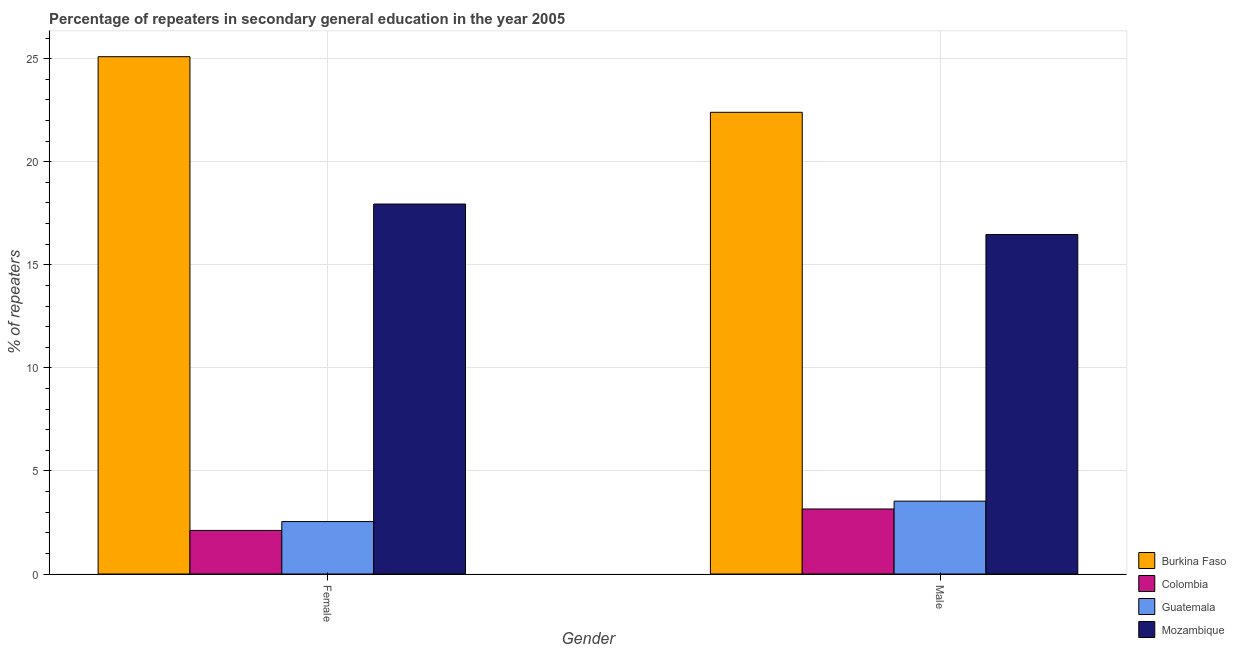How many different coloured bars are there?
Your response must be concise. 4. How many groups of bars are there?
Keep it short and to the point. 2. Are the number of bars per tick equal to the number of legend labels?
Ensure brevity in your answer.  Yes. Are the number of bars on each tick of the X-axis equal?
Your response must be concise. Yes. How many bars are there on the 2nd tick from the left?
Ensure brevity in your answer.  4. How many bars are there on the 2nd tick from the right?
Make the answer very short. 4. What is the label of the 1st group of bars from the left?
Your answer should be very brief. Female. What is the percentage of female repeaters in Colombia?
Your answer should be very brief. 2.11. Across all countries, what is the maximum percentage of female repeaters?
Your response must be concise. 25.1. Across all countries, what is the minimum percentage of male repeaters?
Offer a terse response. 3.15. In which country was the percentage of female repeaters maximum?
Keep it short and to the point. Burkina Faso. What is the total percentage of female repeaters in the graph?
Keep it short and to the point. 47.7. What is the difference between the percentage of female repeaters in Colombia and that in Burkina Faso?
Make the answer very short. -22.98. What is the difference between the percentage of female repeaters in Colombia and the percentage of male repeaters in Guatemala?
Provide a short and direct response. -1.42. What is the average percentage of male repeaters per country?
Provide a succinct answer. 11.39. What is the difference between the percentage of male repeaters and percentage of female repeaters in Burkina Faso?
Your answer should be compact. -2.7. In how many countries, is the percentage of male repeaters greater than 2 %?
Your answer should be very brief. 4. What is the ratio of the percentage of female repeaters in Guatemala to that in Colombia?
Your answer should be very brief. 1.2. What does the 3rd bar from the left in Male represents?
Your response must be concise. Guatemala. How many bars are there?
Offer a terse response. 8. Are all the bars in the graph horizontal?
Your answer should be compact. No. How are the legend labels stacked?
Your answer should be compact. Vertical. What is the title of the graph?
Give a very brief answer. Percentage of repeaters in secondary general education in the year 2005. What is the label or title of the X-axis?
Give a very brief answer. Gender. What is the label or title of the Y-axis?
Your answer should be very brief. % of repeaters. What is the % of repeaters in Burkina Faso in Female?
Ensure brevity in your answer.  25.1. What is the % of repeaters of Colombia in Female?
Offer a terse response. 2.11. What is the % of repeaters of Guatemala in Female?
Your response must be concise. 2.54. What is the % of repeaters of Mozambique in Female?
Keep it short and to the point. 17.95. What is the % of repeaters in Burkina Faso in Male?
Provide a succinct answer. 22.4. What is the % of repeaters of Colombia in Male?
Offer a very short reply. 3.15. What is the % of repeaters in Guatemala in Male?
Ensure brevity in your answer.  3.53. What is the % of repeaters of Mozambique in Male?
Keep it short and to the point. 16.47. Across all Gender, what is the maximum % of repeaters of Burkina Faso?
Your answer should be very brief. 25.1. Across all Gender, what is the maximum % of repeaters of Colombia?
Offer a very short reply. 3.15. Across all Gender, what is the maximum % of repeaters of Guatemala?
Ensure brevity in your answer.  3.53. Across all Gender, what is the maximum % of repeaters of Mozambique?
Your answer should be compact. 17.95. Across all Gender, what is the minimum % of repeaters of Burkina Faso?
Your response must be concise. 22.4. Across all Gender, what is the minimum % of repeaters of Colombia?
Give a very brief answer. 2.11. Across all Gender, what is the minimum % of repeaters of Guatemala?
Give a very brief answer. 2.54. Across all Gender, what is the minimum % of repeaters in Mozambique?
Keep it short and to the point. 16.47. What is the total % of repeaters of Burkina Faso in the graph?
Offer a terse response. 47.49. What is the total % of repeaters of Colombia in the graph?
Provide a short and direct response. 5.27. What is the total % of repeaters in Guatemala in the graph?
Provide a succinct answer. 6.08. What is the total % of repeaters in Mozambique in the graph?
Your answer should be very brief. 34.42. What is the difference between the % of repeaters in Burkina Faso in Female and that in Male?
Provide a short and direct response. 2.7. What is the difference between the % of repeaters in Colombia in Female and that in Male?
Provide a succinct answer. -1.04. What is the difference between the % of repeaters in Guatemala in Female and that in Male?
Your answer should be compact. -0.99. What is the difference between the % of repeaters in Mozambique in Female and that in Male?
Your answer should be compact. 1.48. What is the difference between the % of repeaters of Burkina Faso in Female and the % of repeaters of Colombia in Male?
Offer a terse response. 21.94. What is the difference between the % of repeaters of Burkina Faso in Female and the % of repeaters of Guatemala in Male?
Offer a terse response. 21.56. What is the difference between the % of repeaters in Burkina Faso in Female and the % of repeaters in Mozambique in Male?
Offer a very short reply. 8.63. What is the difference between the % of repeaters in Colombia in Female and the % of repeaters in Guatemala in Male?
Offer a very short reply. -1.42. What is the difference between the % of repeaters in Colombia in Female and the % of repeaters in Mozambique in Male?
Ensure brevity in your answer.  -14.35. What is the difference between the % of repeaters in Guatemala in Female and the % of repeaters in Mozambique in Male?
Provide a succinct answer. -13.93. What is the average % of repeaters in Burkina Faso per Gender?
Provide a succinct answer. 23.75. What is the average % of repeaters in Colombia per Gender?
Give a very brief answer. 2.63. What is the average % of repeaters in Guatemala per Gender?
Your response must be concise. 3.04. What is the average % of repeaters of Mozambique per Gender?
Offer a terse response. 17.21. What is the difference between the % of repeaters of Burkina Faso and % of repeaters of Colombia in Female?
Provide a succinct answer. 22.98. What is the difference between the % of repeaters in Burkina Faso and % of repeaters in Guatemala in Female?
Your answer should be very brief. 22.55. What is the difference between the % of repeaters of Burkina Faso and % of repeaters of Mozambique in Female?
Provide a succinct answer. 7.15. What is the difference between the % of repeaters of Colombia and % of repeaters of Guatemala in Female?
Provide a succinct answer. -0.43. What is the difference between the % of repeaters in Colombia and % of repeaters in Mozambique in Female?
Make the answer very short. -15.83. What is the difference between the % of repeaters of Guatemala and % of repeaters of Mozambique in Female?
Offer a very short reply. -15.4. What is the difference between the % of repeaters in Burkina Faso and % of repeaters in Colombia in Male?
Offer a terse response. 19.24. What is the difference between the % of repeaters in Burkina Faso and % of repeaters in Guatemala in Male?
Ensure brevity in your answer.  18.86. What is the difference between the % of repeaters of Burkina Faso and % of repeaters of Mozambique in Male?
Your answer should be very brief. 5.93. What is the difference between the % of repeaters of Colombia and % of repeaters of Guatemala in Male?
Your response must be concise. -0.38. What is the difference between the % of repeaters in Colombia and % of repeaters in Mozambique in Male?
Give a very brief answer. -13.31. What is the difference between the % of repeaters of Guatemala and % of repeaters of Mozambique in Male?
Offer a very short reply. -12.93. What is the ratio of the % of repeaters in Burkina Faso in Female to that in Male?
Offer a very short reply. 1.12. What is the ratio of the % of repeaters of Colombia in Female to that in Male?
Provide a short and direct response. 0.67. What is the ratio of the % of repeaters in Guatemala in Female to that in Male?
Your response must be concise. 0.72. What is the ratio of the % of repeaters of Mozambique in Female to that in Male?
Offer a very short reply. 1.09. What is the difference between the highest and the second highest % of repeaters of Burkina Faso?
Ensure brevity in your answer.  2.7. What is the difference between the highest and the second highest % of repeaters in Colombia?
Offer a very short reply. 1.04. What is the difference between the highest and the second highest % of repeaters in Guatemala?
Your response must be concise. 0.99. What is the difference between the highest and the second highest % of repeaters of Mozambique?
Offer a terse response. 1.48. What is the difference between the highest and the lowest % of repeaters of Burkina Faso?
Your answer should be compact. 2.7. What is the difference between the highest and the lowest % of repeaters of Colombia?
Offer a terse response. 1.04. What is the difference between the highest and the lowest % of repeaters in Mozambique?
Provide a short and direct response. 1.48. 